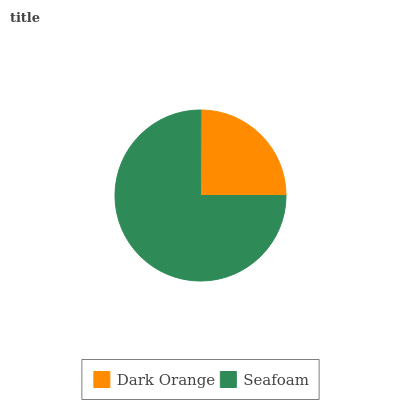Is Dark Orange the minimum?
Answer yes or no. Yes. Is Seafoam the maximum?
Answer yes or no. Yes. Is Seafoam the minimum?
Answer yes or no. No. Is Seafoam greater than Dark Orange?
Answer yes or no. Yes. Is Dark Orange less than Seafoam?
Answer yes or no. Yes. Is Dark Orange greater than Seafoam?
Answer yes or no. No. Is Seafoam less than Dark Orange?
Answer yes or no. No. Is Seafoam the high median?
Answer yes or no. Yes. Is Dark Orange the low median?
Answer yes or no. Yes. Is Dark Orange the high median?
Answer yes or no. No. Is Seafoam the low median?
Answer yes or no. No. 